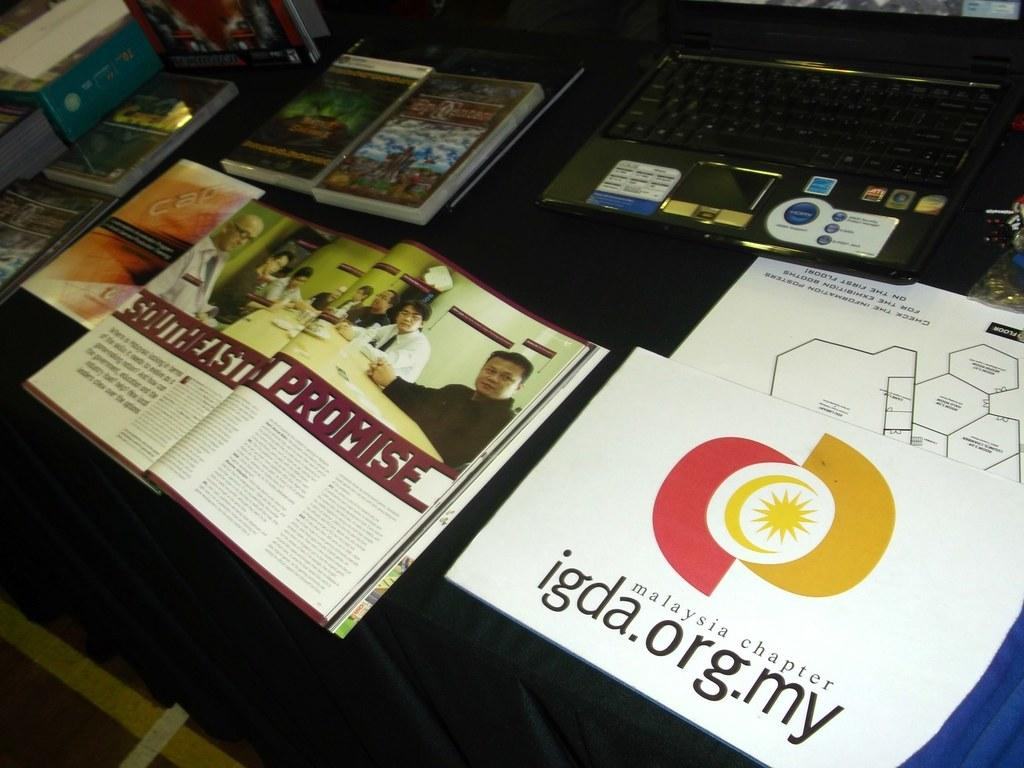<image>
Render a clear and concise summary of the photo. An open magazine with a story on Southeast Promise next to a flyer from the IGDA Malaysia chapter. 